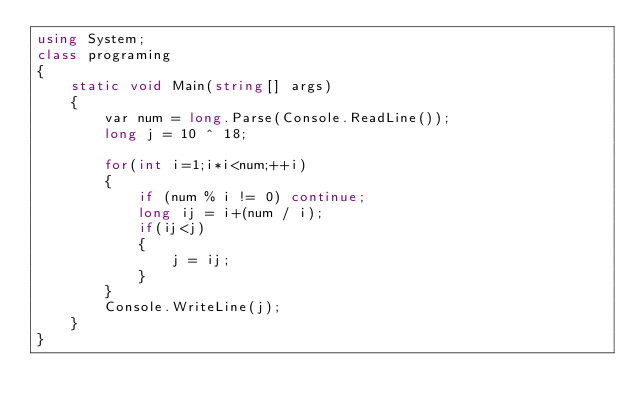<code> <loc_0><loc_0><loc_500><loc_500><_C#_>using System;
class programing
{
    static void Main(string[] args)
    {
        var num = long.Parse(Console.ReadLine());
        long j = 10 ^ 18;

        for(int i=1;i*i<num;++i)
        {
            if (num % i != 0) continue;
            long ij = i+(num / i);
            if(ij<j)
            {
                j = ij;
            }
        }
        Console.WriteLine(j);
    }
}</code> 